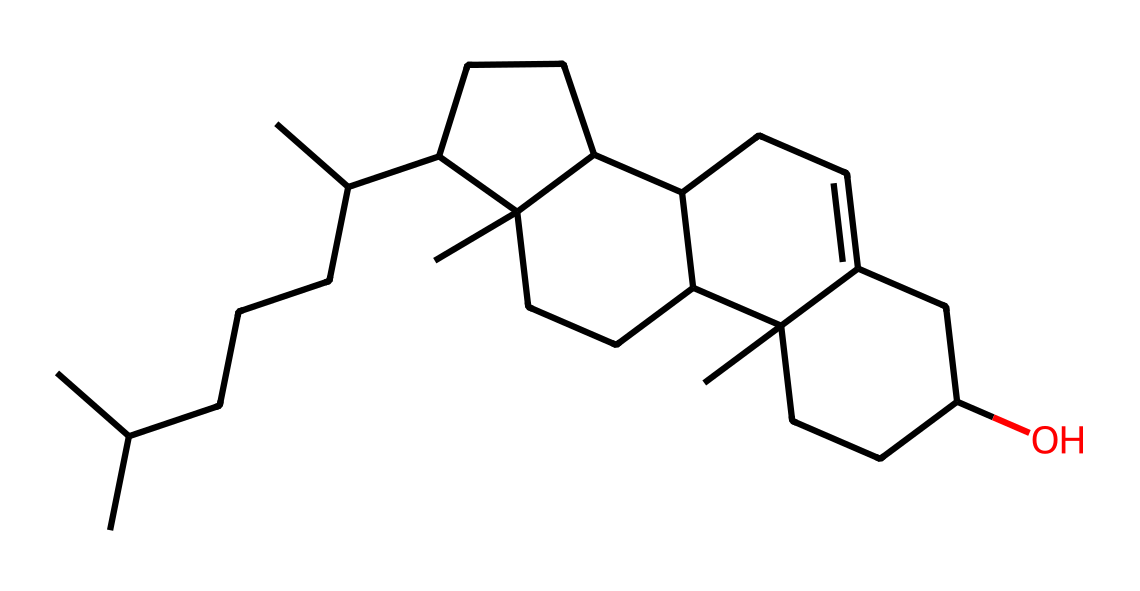What is the molecular formula of cholesterol? To determine the molecular formula, count the number of carbon (C), hydrogen (H), and oxygen (O) atoms in the given SMILES representation. The structure contains 27 carbon atoms, 46 hydrogen atoms, and 1 oxygen atom, yielding the formula C27H46O.
Answer: C27H46O How many rings are present in the cholesterol structure? By analyzing the cholesterol structure, we can identify the number of cyclic components. Cholesterol has four interconnected rings (three six-membered and one five-membered), which are characteristic of its steroid structure.
Answer: four What is the functional group present in cholesterol? In the structural representation, there is a hydroxyl (–OH) group attached to one of the carbons, indicating that cholesterol belongs to the alcohol class of compounds. This –OH group classifies it as a sterol.
Answer: hydroxyl group What role does cholesterol play in hormone production? Cholesterol serves as a precursor for the synthesis of steroid hormones, which are crucial in various physiological processes, including stress response and sexual development. This role is significant for athletes who rely on these hormones for performance and recovery.
Answer: precursor for steroid hormones Which type of lipid does cholesterol belong to? Cholesterol is classified as a sterol, which is a category of steroids. This classification arises from its structure, which features multiple fused ring systems with functional groups.
Answer: sterol 